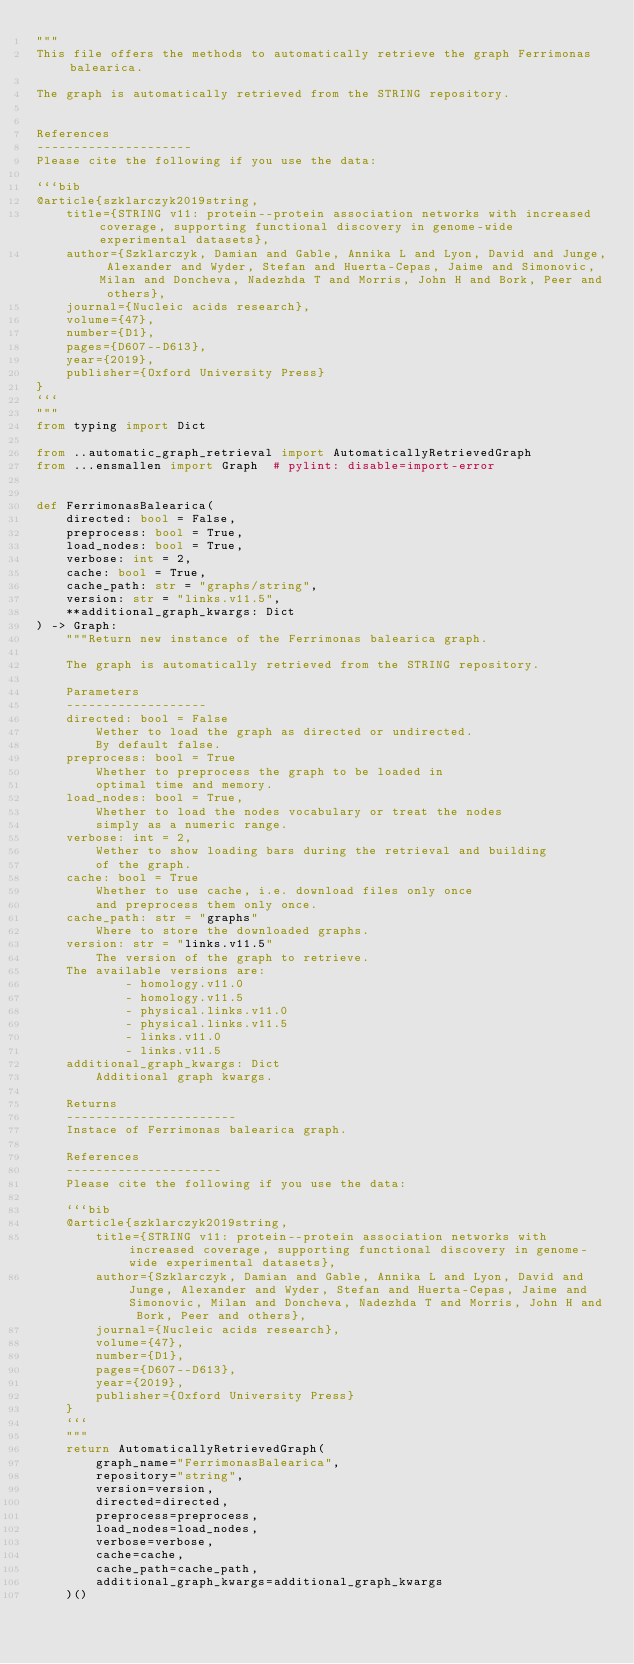<code> <loc_0><loc_0><loc_500><loc_500><_Python_>"""
This file offers the methods to automatically retrieve the graph Ferrimonas balearica.

The graph is automatically retrieved from the STRING repository. 


References
---------------------
Please cite the following if you use the data:

```bib
@article{szklarczyk2019string,
    title={STRING v11: protein--protein association networks with increased coverage, supporting functional discovery in genome-wide experimental datasets},
    author={Szklarczyk, Damian and Gable, Annika L and Lyon, David and Junge, Alexander and Wyder, Stefan and Huerta-Cepas, Jaime and Simonovic, Milan and Doncheva, Nadezhda T and Morris, John H and Bork, Peer and others},
    journal={Nucleic acids research},
    volume={47},
    number={D1},
    pages={D607--D613},
    year={2019},
    publisher={Oxford University Press}
}
```
"""
from typing import Dict

from ..automatic_graph_retrieval import AutomaticallyRetrievedGraph
from ...ensmallen import Graph  # pylint: disable=import-error


def FerrimonasBalearica(
    directed: bool = False,
    preprocess: bool = True,
    load_nodes: bool = True,
    verbose: int = 2,
    cache: bool = True,
    cache_path: str = "graphs/string",
    version: str = "links.v11.5",
    **additional_graph_kwargs: Dict
) -> Graph:
    """Return new instance of the Ferrimonas balearica graph.

    The graph is automatically retrieved from the STRING repository.	

    Parameters
    -------------------
    directed: bool = False
        Wether to load the graph as directed or undirected.
        By default false.
    preprocess: bool = True
        Whether to preprocess the graph to be loaded in 
        optimal time and memory.
    load_nodes: bool = True,
        Whether to load the nodes vocabulary or treat the nodes
        simply as a numeric range.
    verbose: int = 2,
        Wether to show loading bars during the retrieval and building
        of the graph.
    cache: bool = True
        Whether to use cache, i.e. download files only once
        and preprocess them only once.
    cache_path: str = "graphs"
        Where to store the downloaded graphs.
    version: str = "links.v11.5"
        The version of the graph to retrieve.		
	The available versions are:
			- homology.v11.0
			- homology.v11.5
			- physical.links.v11.0
			- physical.links.v11.5
			- links.v11.0
			- links.v11.5
    additional_graph_kwargs: Dict
        Additional graph kwargs.

    Returns
    -----------------------
    Instace of Ferrimonas balearica graph.

	References
	---------------------
	Please cite the following if you use the data:
	
	```bib
	@article{szklarczyk2019string,
	    title={STRING v11: protein--protein association networks with increased coverage, supporting functional discovery in genome-wide experimental datasets},
	    author={Szklarczyk, Damian and Gable, Annika L and Lyon, David and Junge, Alexander and Wyder, Stefan and Huerta-Cepas, Jaime and Simonovic, Milan and Doncheva, Nadezhda T and Morris, John H and Bork, Peer and others},
	    journal={Nucleic acids research},
	    volume={47},
	    number={D1},
	    pages={D607--D613},
	    year={2019},
	    publisher={Oxford University Press}
	}
	```
    """
    return AutomaticallyRetrievedGraph(
        graph_name="FerrimonasBalearica",
        repository="string",
        version=version,
        directed=directed,
        preprocess=preprocess,
        load_nodes=load_nodes,
        verbose=verbose,
        cache=cache,
        cache_path=cache_path,
        additional_graph_kwargs=additional_graph_kwargs
    )()
</code> 